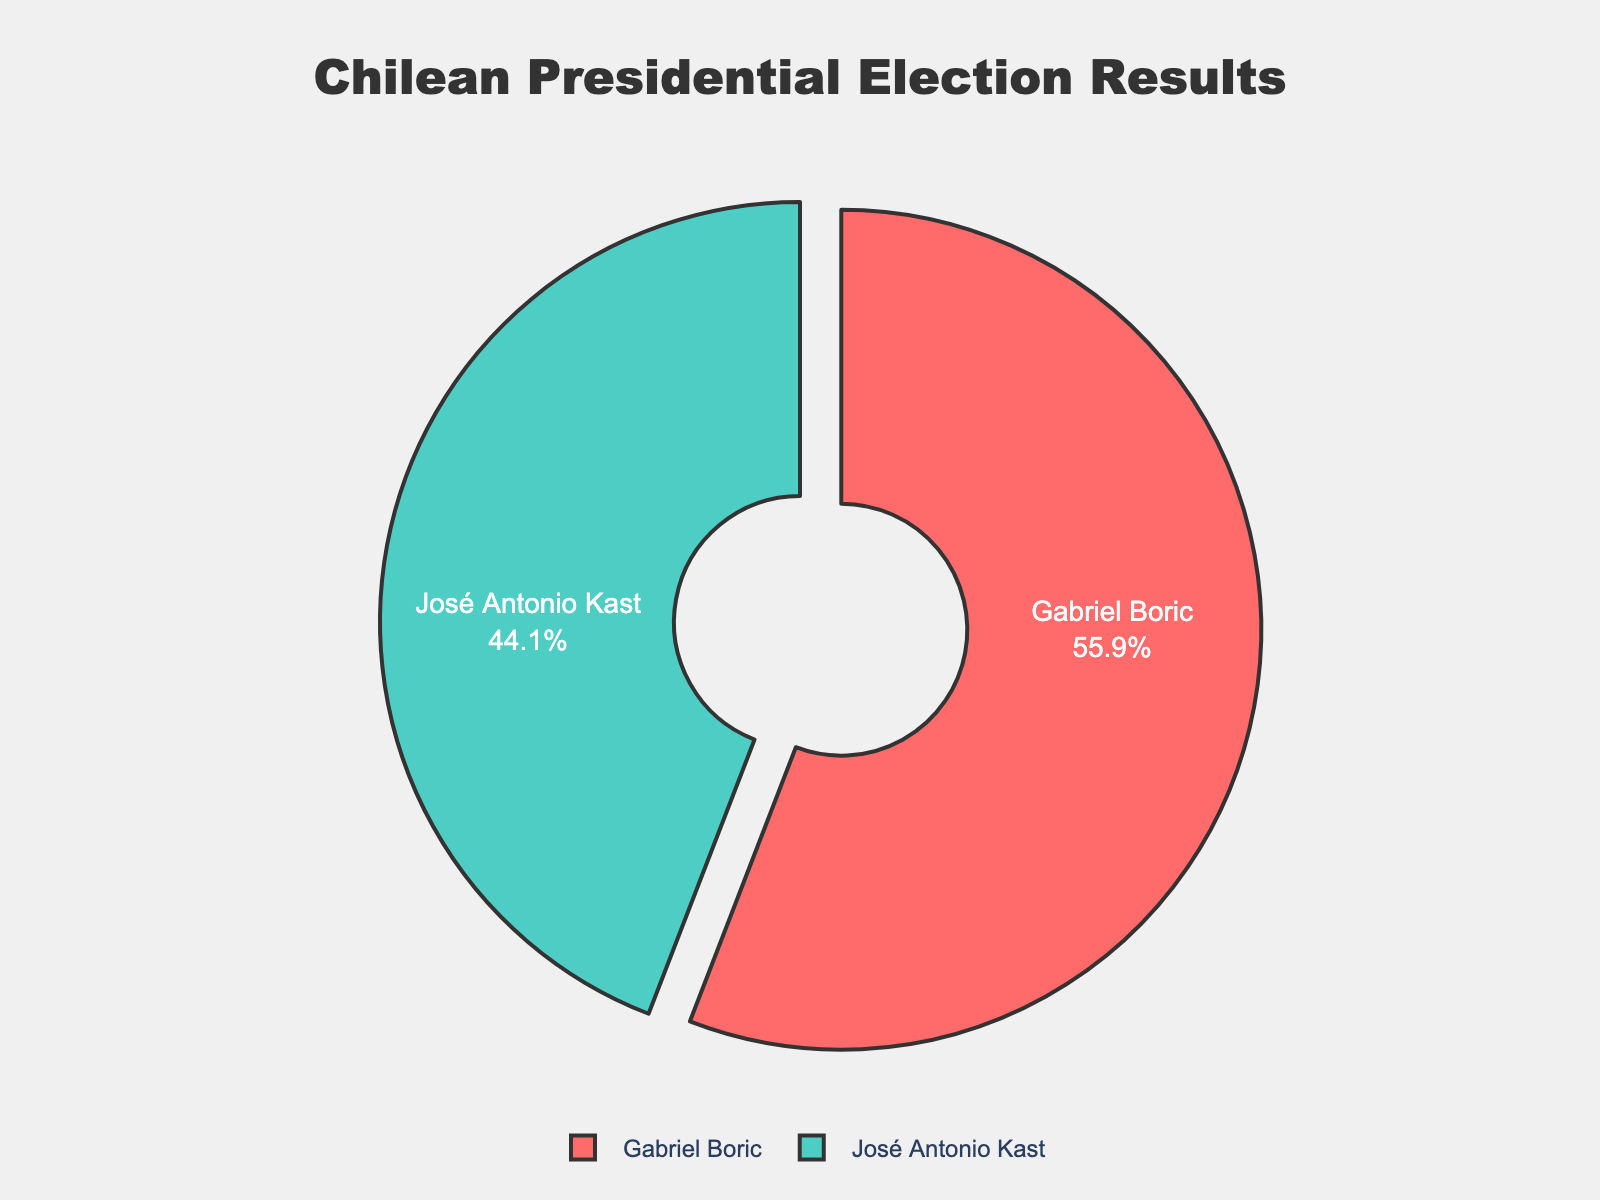Which candidate won the most recent Chilean presidential election? Look at the pie chart and find the candidate with the largest segment. The segment size indicates the vote percentage each candidate received. Gabriel Boric has the largest segment.
Answer: Gabriel Boric What percentage of the vote did José Antonio Kast receive? Examine the pie chart for the segment labeled 'José Antonio Kast.' The percentage displayed next to his name represents his share of the vote.
Answer: 44.13% How much more percentage did Gabriel Boric get compared to José Antonio Kast? Subtract José Antonio Kast's percentage from Gabriel Boric's percentage. Gabriel Boric received 55.87% and José Antonio Kast received 44.13%. So, 55.87 - 44.13 = 11.74.
Answer: 11.74% What is the total percentage of votes that the remaining candidates received combined? All other candidates listed have 0% each, so their combined percentage is 0 + 0 + 0 + 0 + 0 = 0.
Answer: 0% What is the combined percentage of votes received by the two candidates shown in the pie chart? Add the percentages of Gabriel Boric and José Antonio Kast, who are the only candidates with non-zero percentages. 55.87% + 44.13% = 100%.
Answer: 100% What color represents Gabriel Boric's segment in the pie chart? Look at the color of the largest segment in the pie chart, which is labeled 'Gabriel Boric.' The color is visually identified in the chart.
Answer: Red Is the percentage received by José Antonio Kast smaller than Gabriel Boric's percentage? Compare the percentages provided in the pie chart. José Antonio Kast's percentage is 44.13%, and Gabriel Boric's percentage is 55.87%. Since 44.13% < 55.87%, it is indeed smaller.
Answer: Yes Who received the least percentage of votes among the candidates shown? Notice that all candidates other than Gabriel Boric and José Antonio Kast have 0%, making any of them the candidates with the least percentage.
Answer: Any of Franco Parisi, Sebastián Sichel, Yasna Provoste, Marco Enríquez-Ominami, Eduardo Artés 